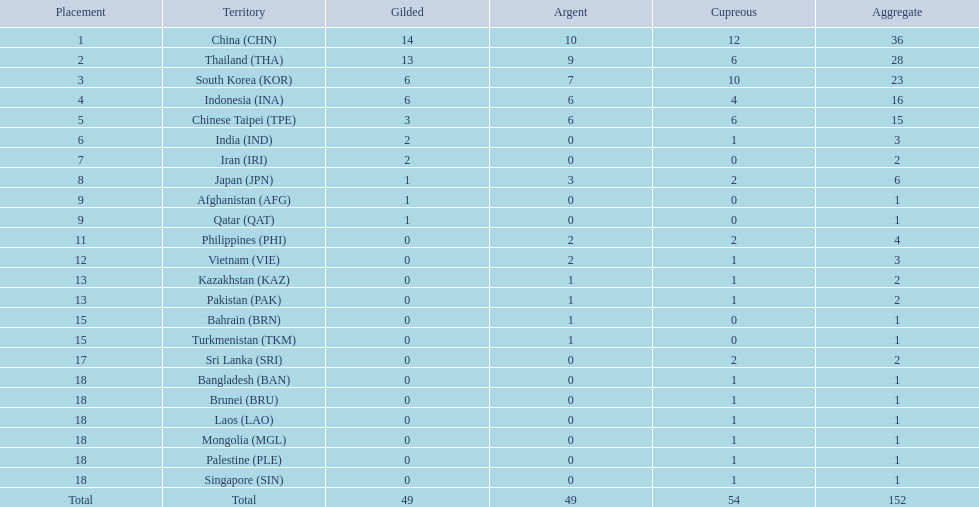How many more medals did india earn compared to pakistan? 1. 